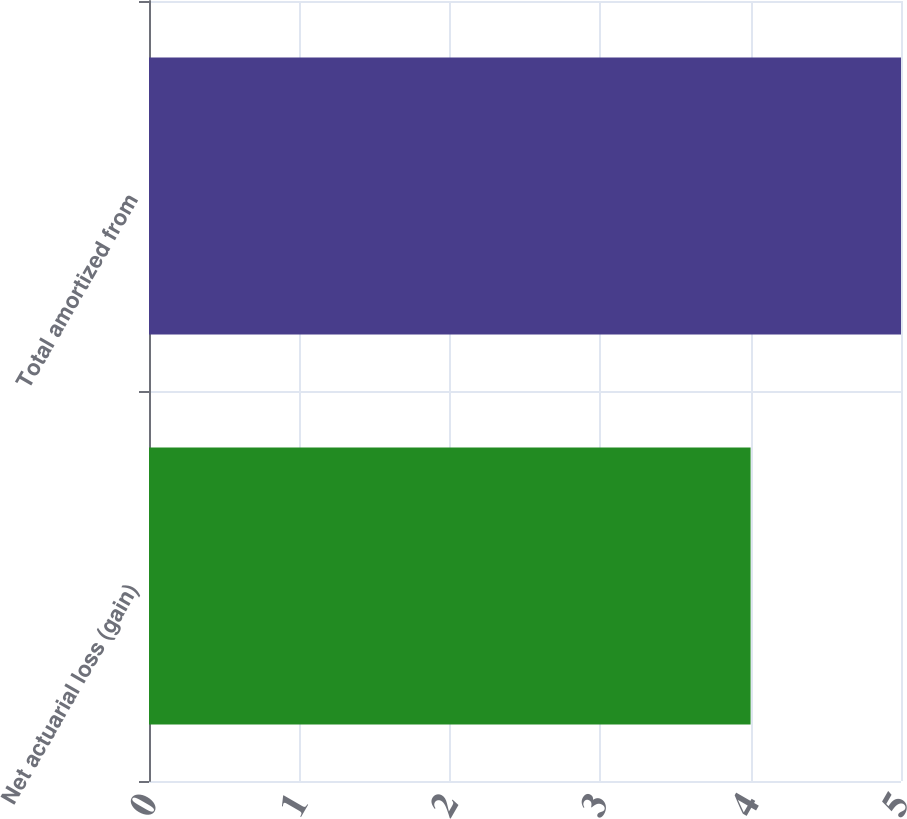Convert chart to OTSL. <chart><loc_0><loc_0><loc_500><loc_500><bar_chart><fcel>Net actuarial loss (gain)<fcel>Total amortized from<nl><fcel>4<fcel>5<nl></chart> 